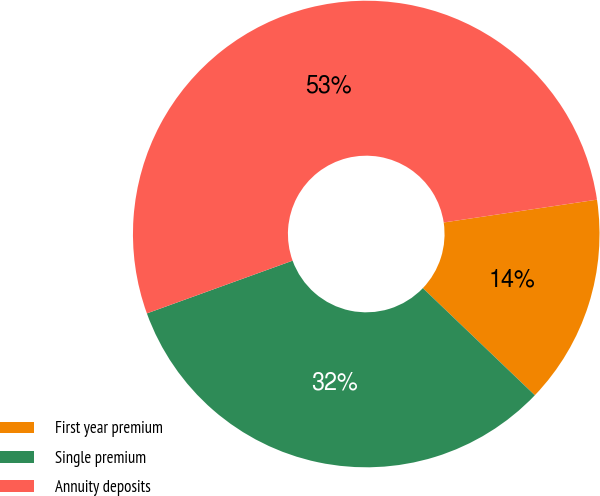Convert chart to OTSL. <chart><loc_0><loc_0><loc_500><loc_500><pie_chart><fcel>First year premium<fcel>Single premium<fcel>Annuity deposits<nl><fcel>14.5%<fcel>32.33%<fcel>53.18%<nl></chart> 